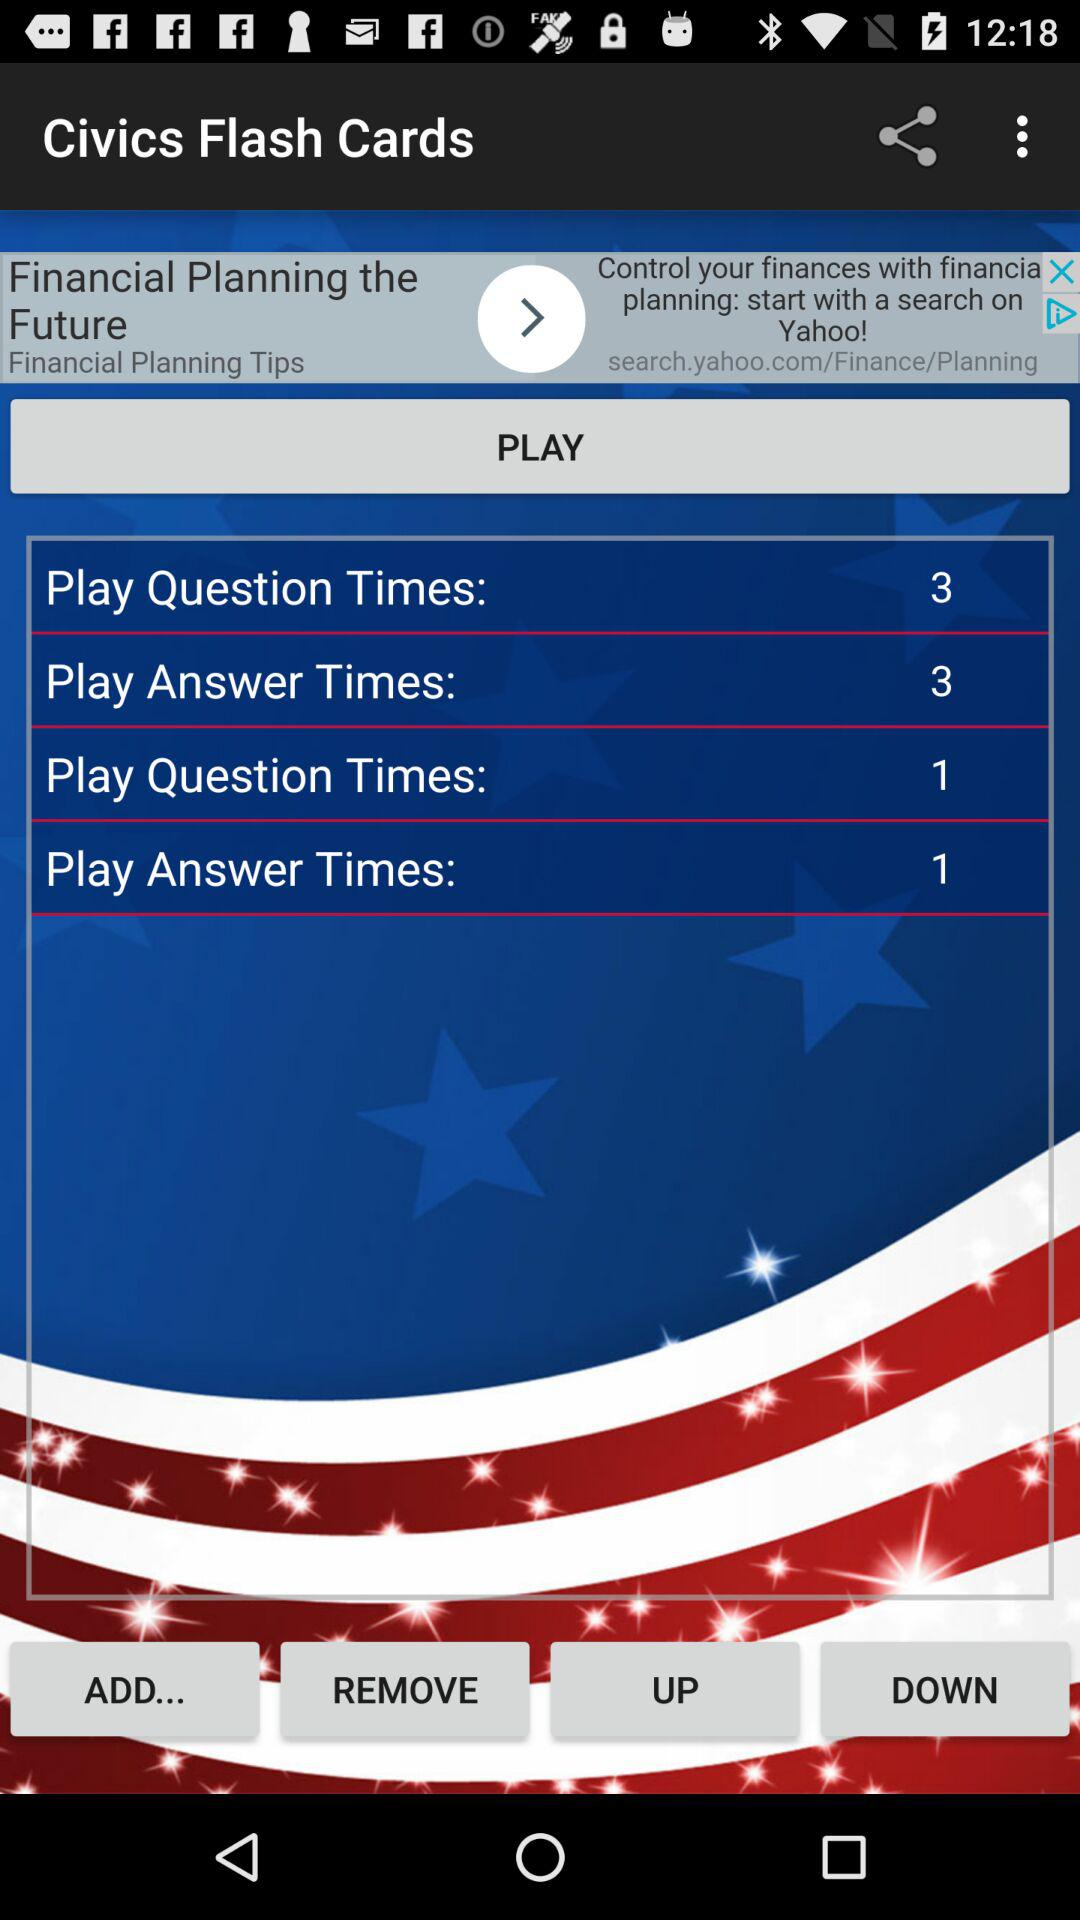What is the count for play answer times?
When the provided information is insufficient, respond with <no answer>. <no answer> 